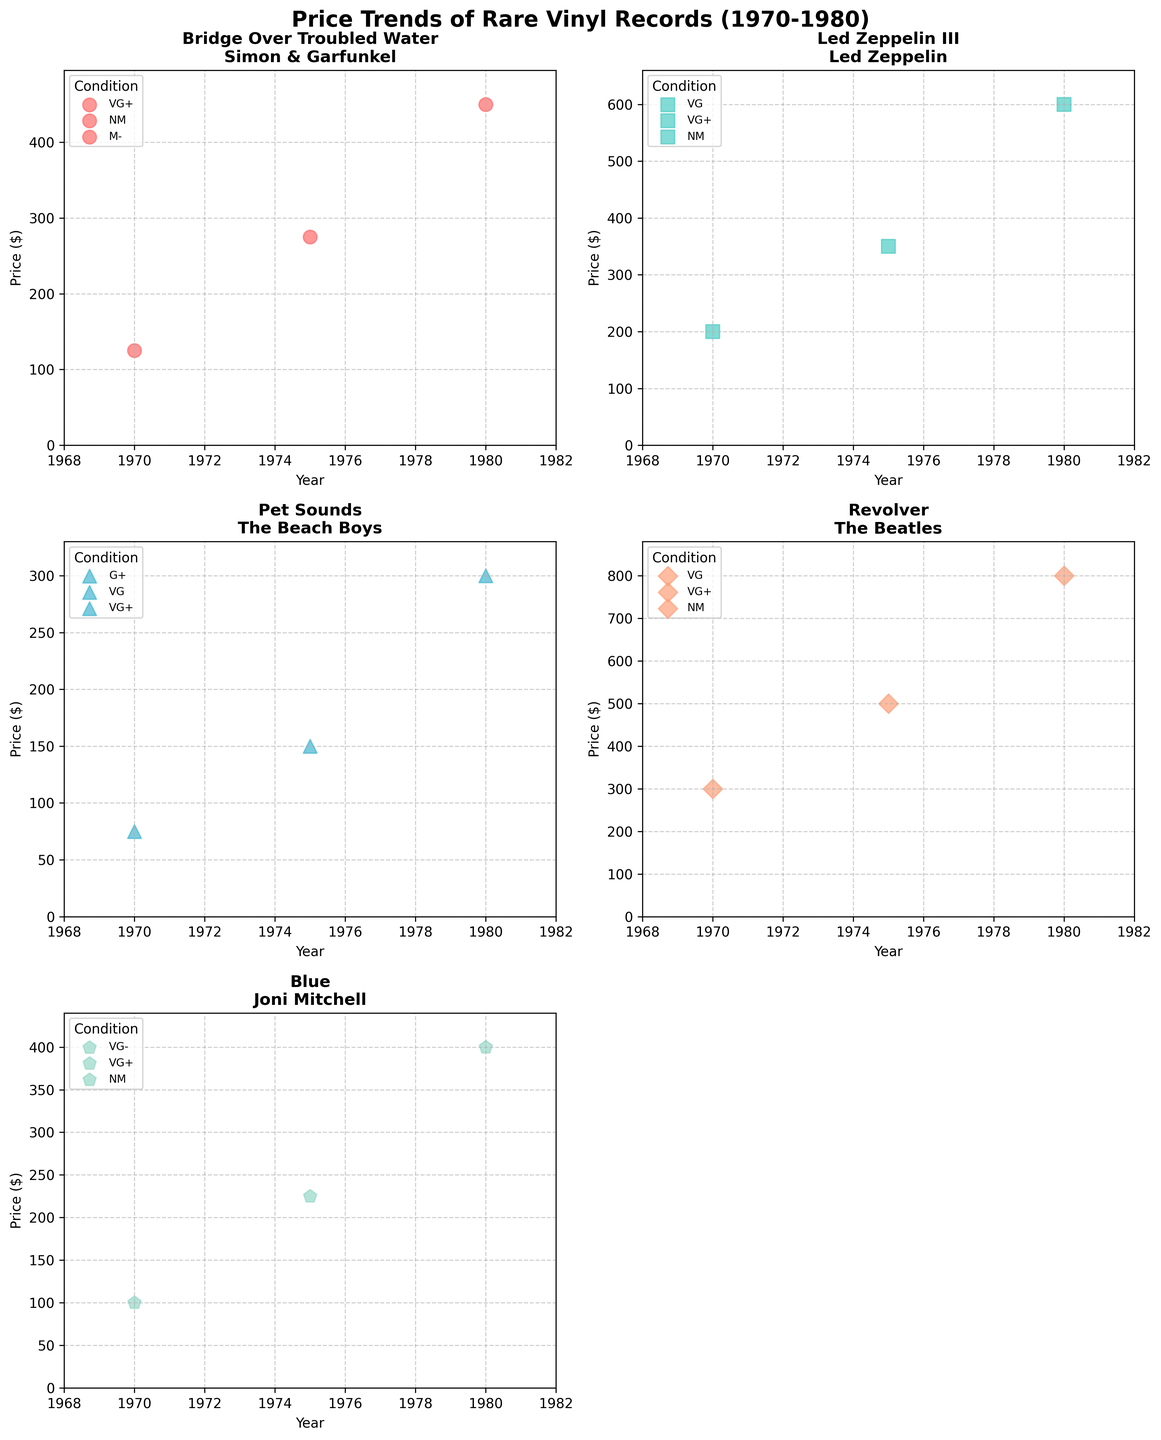what is the highest price for "Revolver" by The Beatles? First, locate the subplot for "Revolver" by The Beatles. Then, identify the data point with the highest price in the condition legend.
Answer: 800 What is the number of distinct condition grades for "Bridge Over Troubled Water"? Identify the "Bridge Over Troubled Water" subplot. Count the distinct condition grades in the legend.
Answer: 3 What is the price trend for "Pet Sounds" by The Beach Boys? Check the scatter points of "Pet Sounds" over the years 1970, 1975, and 1980. Note that prices rise from 75 to 300.
Answer: Increasing Which album has the highest price in 1980? Inspect the subplots and find the highest price point in 1980. Compare it across all albums. "Revolver" has the highest price of 800 in 1980.
Answer: "Revolver" How many albums are displayed in the figure? Count the number of subplots corresponding to different albums.
Answer: 5 What is the price increase for "Led Zeppelin III" from 1975 to 1980? Find the "Led Zeppelin III" subplot and subtract the 1975 price point from the 1980 price point: 600 - 350 = 250.
Answer: 250 Which album has the greatest price increase from 1970 to 1980? Compare the 1970 and 1980 prices for all albums in their respective subplots. "Revolver" shows the maximum increase (800 - 300 = 500).
Answer: "Revolver" Did "Blue" by Joni Mitchell have its highest price in 1980? Refer to the "Blue" subplot and review the price points across 1970, 1975, and 1980 to confirm.
Answer: Yes 